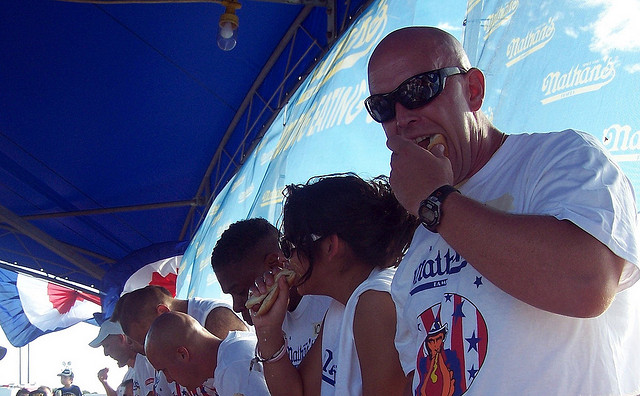<image>What is the company name on their shirts? I am not sure. The company name on their shirts can be 'new york', "nathan's", 'mananes', 'uncle sam', 'fruits'. What is the company name on their shirts? I am not sure about the company name on their shirts. It can be seen 'nathan's', 'mananes', 'uncle sam', 'fruits', or 'new york'. 